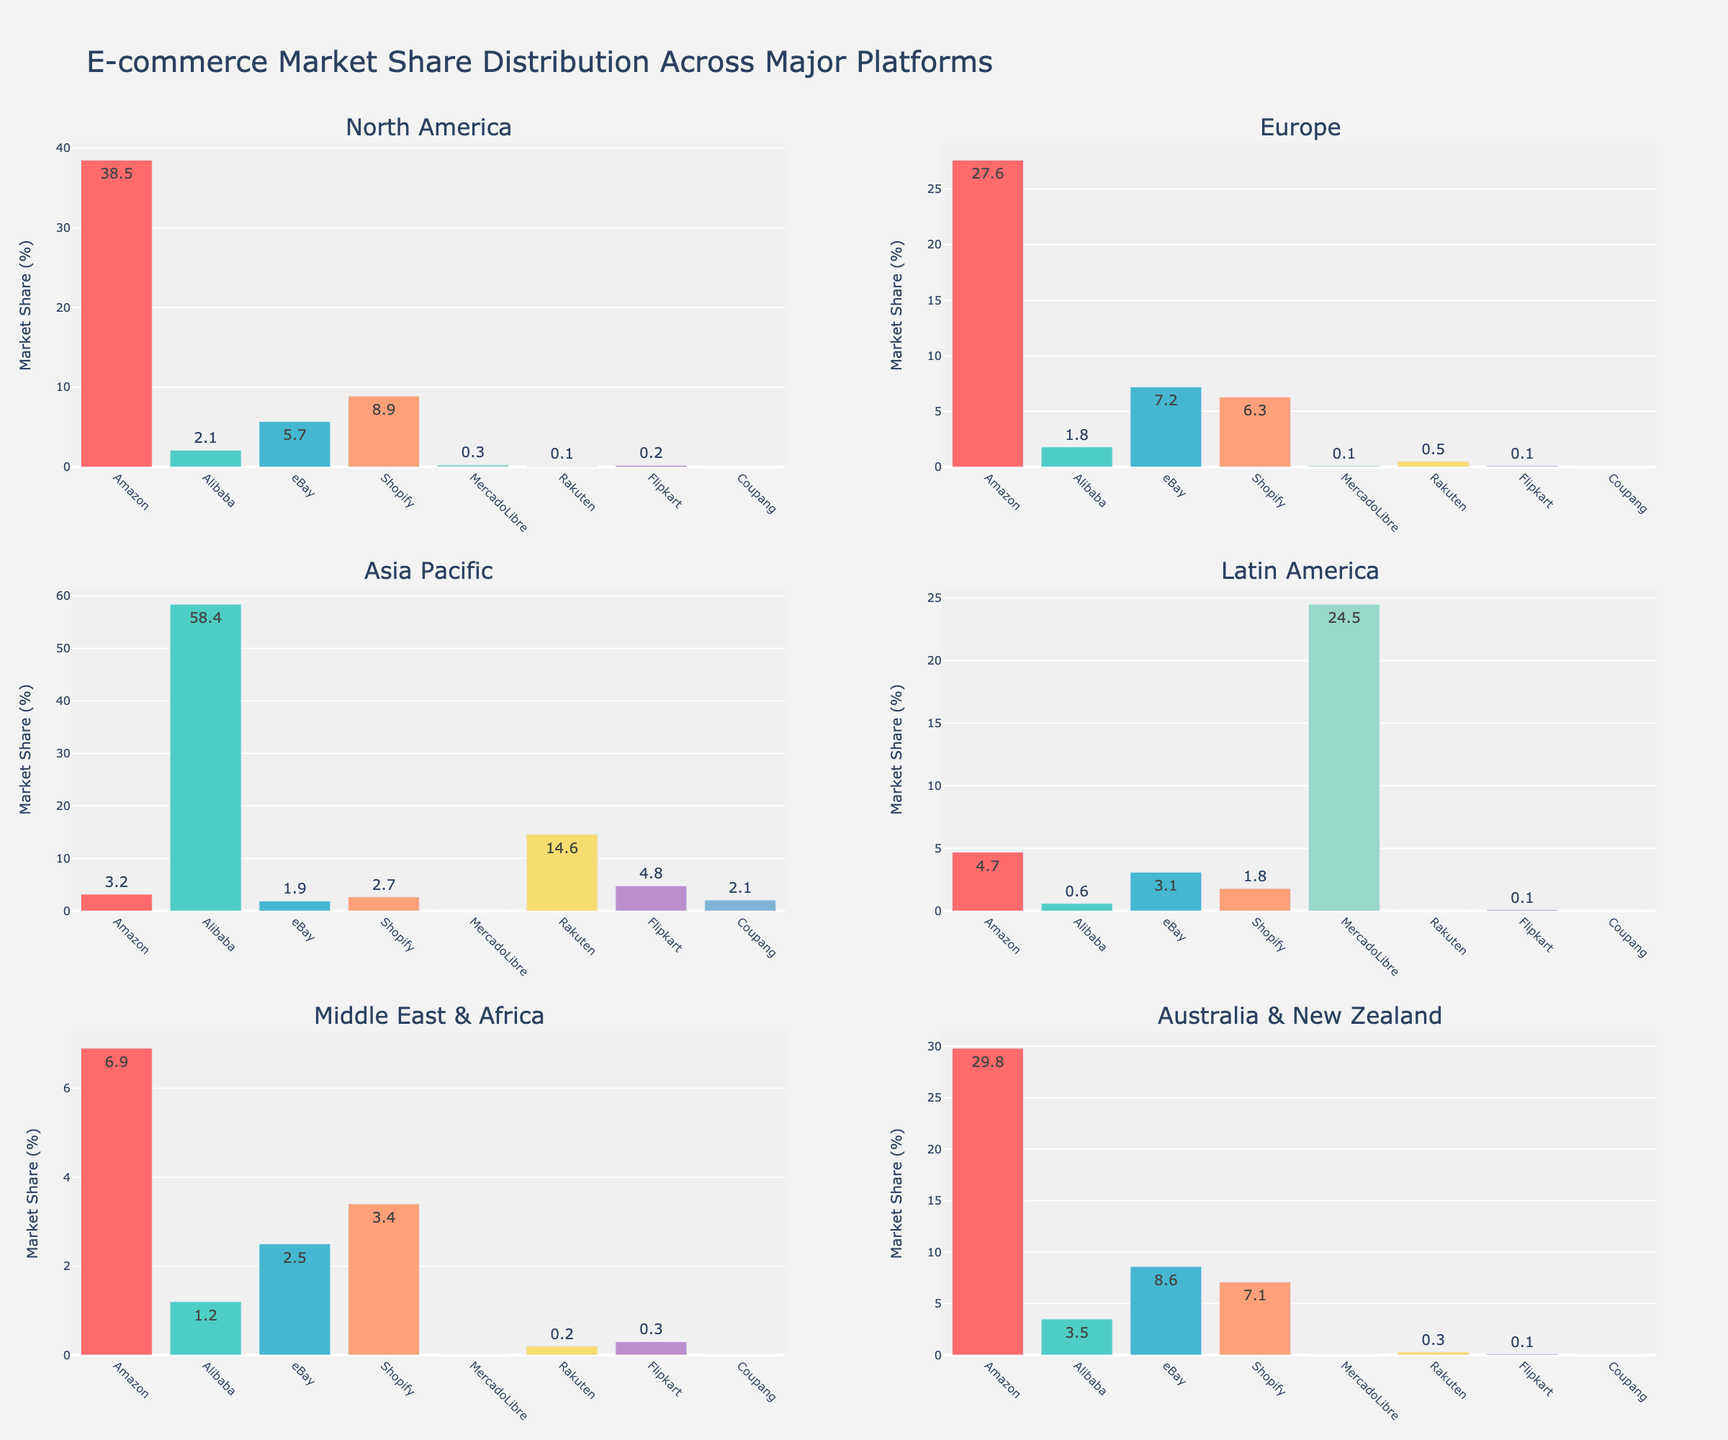Which region has the highest market share for Amazon? By looking at the bar heights, specifically for the Amazon bars, North America has the tallest bar, indicating the highest market share for Amazon.
Answer: North America Which platform has the dominant market share in the Asia Pacific region? The bar for Alibaba in the Asia Pacific subplot is significantly taller than the others, indicating it has the dominant market share.
Answer: Alibaba In which region does Shopify have a market share close to Alibaba's? By comparing the bar heights for Shopify and Alibaba in different subplots, the Australia & New Zealand region shows Shopify with a market share of 7.1% and Alibaba with a close 3.5%.
Answer: Australia & New Zealand Sum the market share of eBay and Flipkart in the Middle East & Africa region. The market share for eBay in the Middle East & Africa is 2.5%, and for Flipkart, it's 0.3%. Adding both values gives 2.5% + 0.3% = 2.8%.
Answer: 2.8% Which platform has the smallest market share in Latin America? By checking all bars in the Latin America subplot, Shopify has the smallest market share at 1.8%.
Answer: Shopify How does Alibaba's market share in Europe compare to that in North America? The bar for Alibaba in Europe shows a market share of 1.8%, while in North America, it's 2.1%. Alibaba's market share in Europe is slightly less than in North America.
Answer: Europe < North America Is Amazon's market share in Australia & New Zealand higher than in Europe? The Amazon bar in the Australia & New Zealand subplot is at 29.8%, while in Europe, it is at 27.6%. Thus, it's higher in Australia & New Zealand.
Answer: Yes What is the difference in the market share of Alibaba between the Asia Pacific and Latin America? Alibaba's market share is 58.4% in the Asia Pacific and 0.6% in Latin America. The difference is 58.4% - 0.6% = 57.8%.
Answer: 57.8% Which region has the least variety in e-commerce platform market shares, judging by the uniformity of bar heights? All regions have a range of bar heights, but Latin America has the least variety, as Alibaba, eBay, and Shopify all hover around low values except for MercadoLibre.
Answer: Latin America 